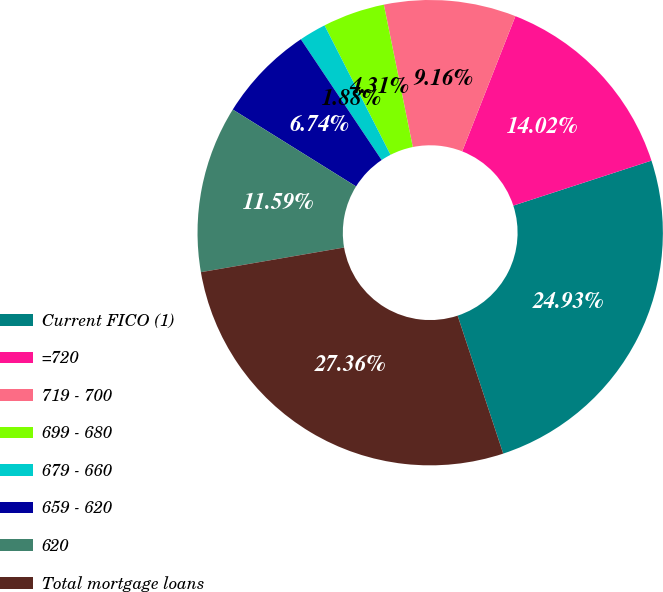Convert chart. <chart><loc_0><loc_0><loc_500><loc_500><pie_chart><fcel>Current FICO (1)<fcel>=720<fcel>719 - 700<fcel>699 - 680<fcel>679 - 660<fcel>659 - 620<fcel>620<fcel>Total mortgage loans<nl><fcel>24.93%<fcel>14.02%<fcel>9.16%<fcel>4.31%<fcel>1.88%<fcel>6.74%<fcel>11.59%<fcel>27.36%<nl></chart> 